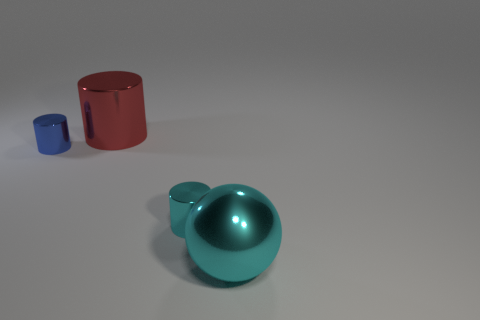What kind of material do these objects look like they're made out of? The objects in the image seem to have a metallic finish. The reflective surfaces and the way light interacts with the objects suggest that they could be made of some type of metal. 